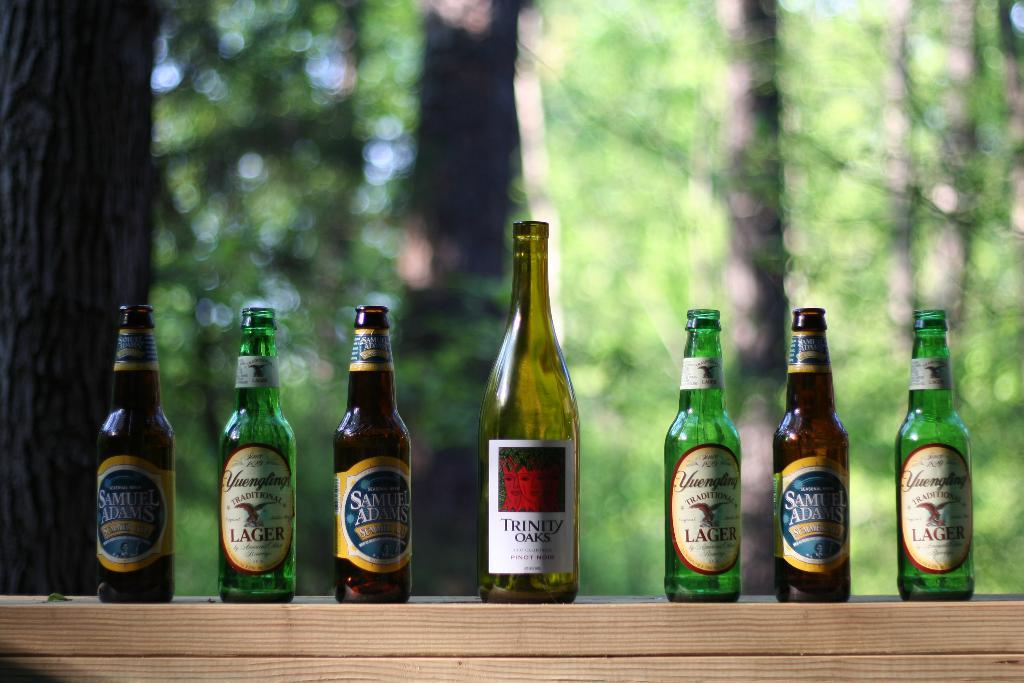Provide a one-sentence caption for the provided image. Different brands of beer bottles line each side of a Trinity Oaks wine bottle in the center, arranged on an outdoor shelf. 